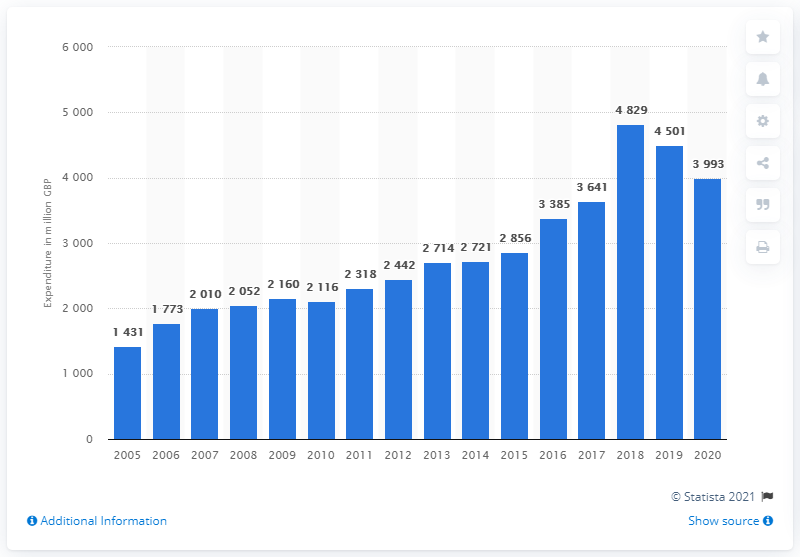Identify some key points in this picture. The total expenditure on veterinary services in the UK in 2020 was 3993. 